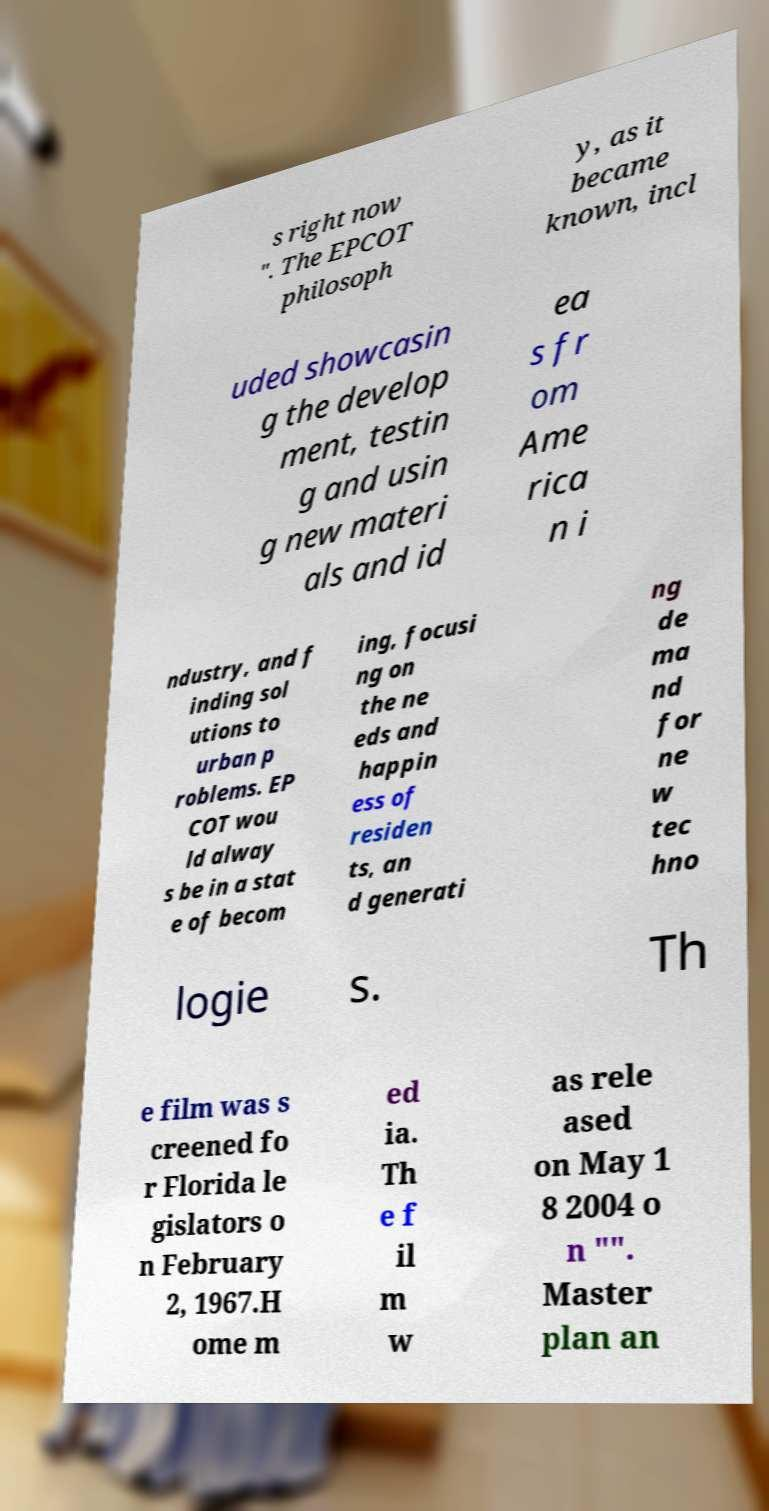Please read and relay the text visible in this image. What does it say? s right now ". The EPCOT philosoph y, as it became known, incl uded showcasin g the develop ment, testin g and usin g new materi als and id ea s fr om Ame rica n i ndustry, and f inding sol utions to urban p roblems. EP COT wou ld alway s be in a stat e of becom ing, focusi ng on the ne eds and happin ess of residen ts, an d generati ng de ma nd for ne w tec hno logie s. Th e film was s creened fo r Florida le gislators o n February 2, 1967.H ome m ed ia. Th e f il m w as rele ased on May 1 8 2004 o n "". Master plan an 